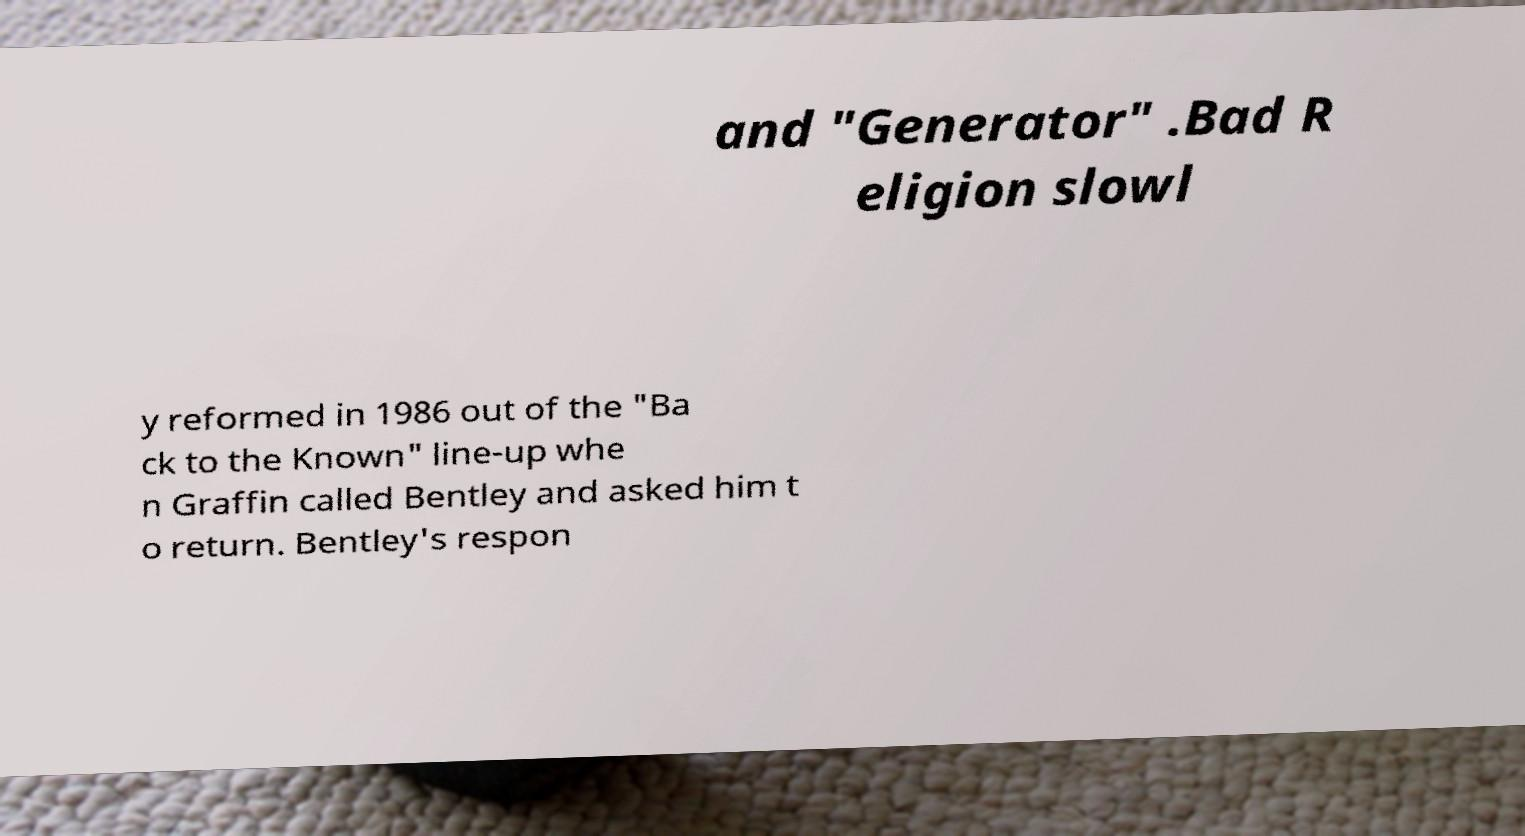Could you extract and type out the text from this image? and "Generator" .Bad R eligion slowl y reformed in 1986 out of the "Ba ck to the Known" line-up whe n Graffin called Bentley and asked him t o return. Bentley's respon 